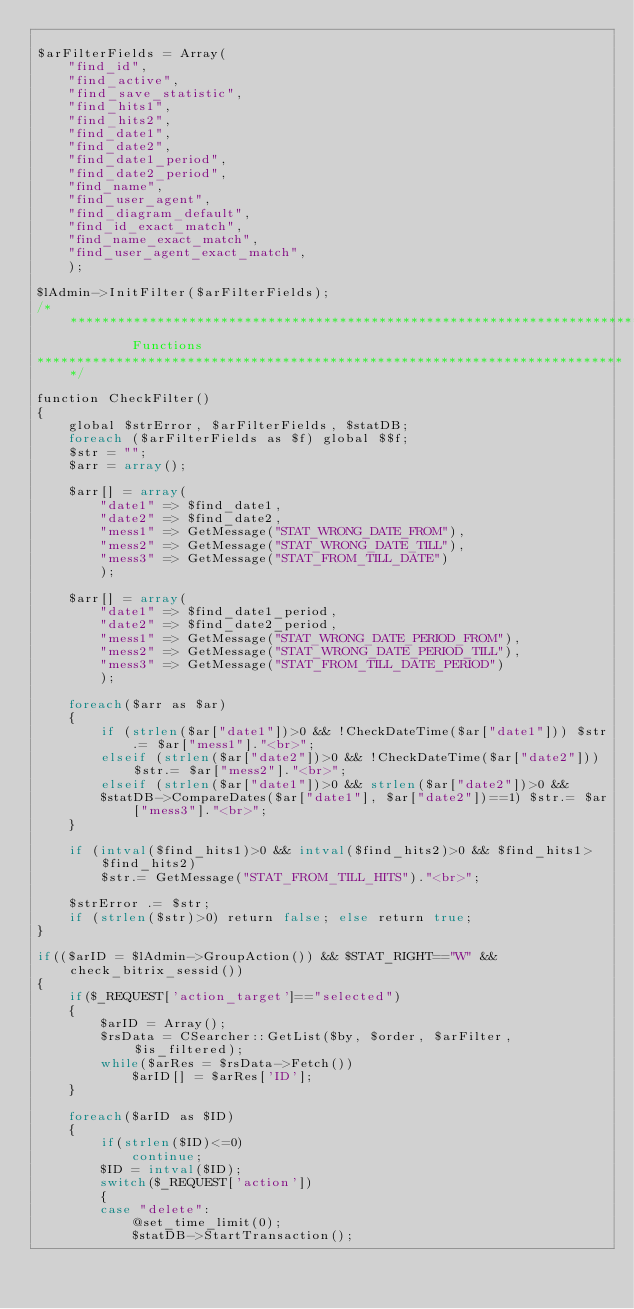Convert code to text. <code><loc_0><loc_0><loc_500><loc_500><_PHP_>
$arFilterFields = Array(
	"find_id",
	"find_active",
	"find_save_statistic",
	"find_hits1",
	"find_hits2",
	"find_date1",
	"find_date2",
	"find_date1_period",
	"find_date2_period",
	"find_name",
	"find_user_agent",
	"find_diagram_default",
	"find_id_exact_match",
	"find_name_exact_match",
	"find_user_agent_exact_match",
	);

$lAdmin->InitFilter($arFilterFields);
/***************************************************************************
			Functions
***************************************************************************/

function CheckFilter()
{
	global $strError, $arFilterFields, $statDB;
	foreach ($arFilterFields as $f) global $$f;
	$str = "";
	$arr = array();

	$arr[] = array(
		"date1" => $find_date1,
		"date2" => $find_date2,
		"mess1" => GetMessage("STAT_WRONG_DATE_FROM"),
		"mess2" => GetMessage("STAT_WRONG_DATE_TILL"),
		"mess3" => GetMessage("STAT_FROM_TILL_DATE")
		);

	$arr[] = array(
		"date1" => $find_date1_period,
		"date2" => $find_date2_period,
		"mess1" => GetMessage("STAT_WRONG_DATE_PERIOD_FROM"),
		"mess2" => GetMessage("STAT_WRONG_DATE_PERIOD_TILL"),
		"mess3" => GetMessage("STAT_FROM_TILL_DATE_PERIOD")
		);

	foreach($arr as $ar)
	{
		if (strlen($ar["date1"])>0 && !CheckDateTime($ar["date1"])) $str.= $ar["mess1"]."<br>";
		elseif (strlen($ar["date2"])>0 && !CheckDateTime($ar["date2"])) $str.= $ar["mess2"]."<br>";
		elseif (strlen($ar["date1"])>0 && strlen($ar["date2"])>0 &&
		$statDB->CompareDates($ar["date1"], $ar["date2"])==1) $str.= $ar["mess3"]."<br>";
	}

	if (intval($find_hits1)>0 && intval($find_hits2)>0 && $find_hits1>$find_hits2)
		$str.= GetMessage("STAT_FROM_TILL_HITS")."<br>";

	$strError .= $str;
	if (strlen($str)>0) return false; else return true;
}

if(($arID = $lAdmin->GroupAction()) && $STAT_RIGHT=="W" && check_bitrix_sessid())
{
	if($_REQUEST['action_target']=="selected")
	{
		$arID = Array();
		$rsData = CSearcher::GetList($by, $order, $arFilter, $is_filtered);
		while($arRes = $rsData->Fetch())
			$arID[] = $arRes['ID'];
	}

	foreach($arID as $ID)
	{
		if(strlen($ID)<=0)
			continue;
		$ID = intval($ID);
		switch($_REQUEST['action'])
		{
		case "delete":
			@set_time_limit(0);
			$statDB->StartTransaction();</code> 